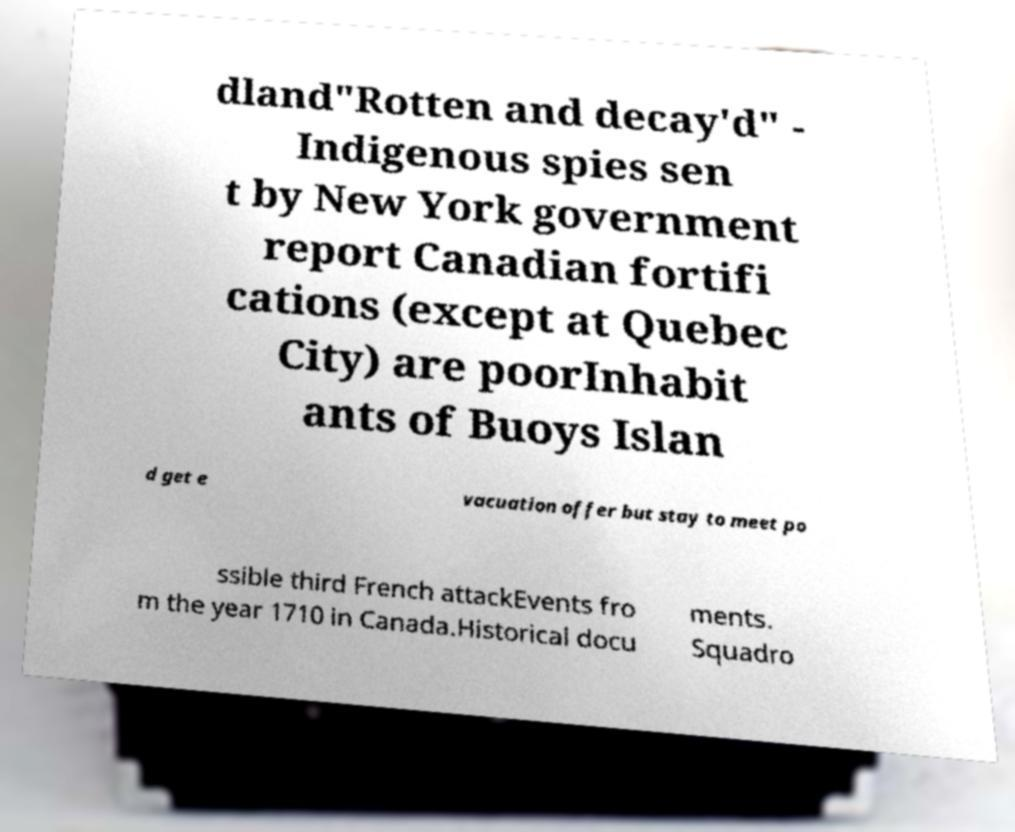I need the written content from this picture converted into text. Can you do that? dland"Rotten and decay'd" - Indigenous spies sen t by New York government report Canadian fortifi cations (except at Quebec City) are poorInhabit ants of Buoys Islan d get e vacuation offer but stay to meet po ssible third French attackEvents fro m the year 1710 in Canada.Historical docu ments. Squadro 